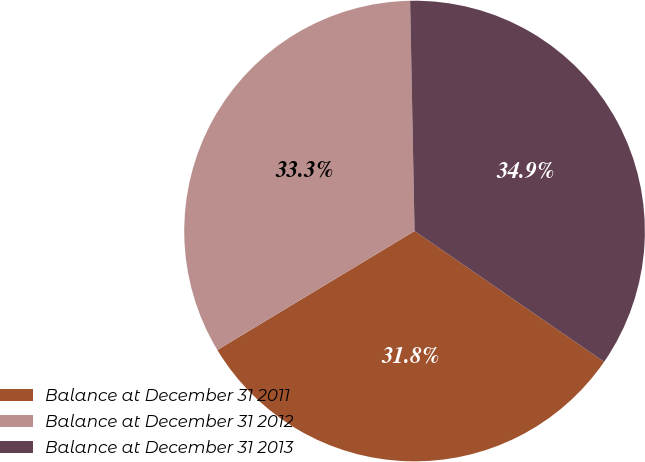<chart> <loc_0><loc_0><loc_500><loc_500><pie_chart><fcel>Balance at December 31 2011<fcel>Balance at December 31 2012<fcel>Balance at December 31 2013<nl><fcel>31.75%<fcel>33.33%<fcel>34.92%<nl></chart> 